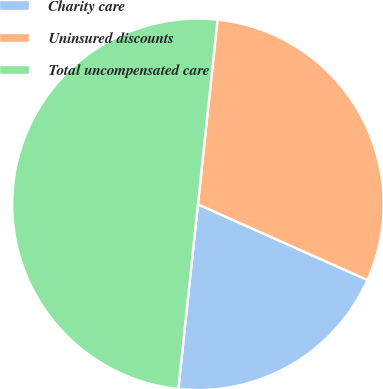Convert chart to OTSL. <chart><loc_0><loc_0><loc_500><loc_500><pie_chart><fcel>Charity care<fcel>Uninsured discounts<fcel>Total uncompensated care<nl><fcel>20.0%<fcel>30.0%<fcel>50.0%<nl></chart> 